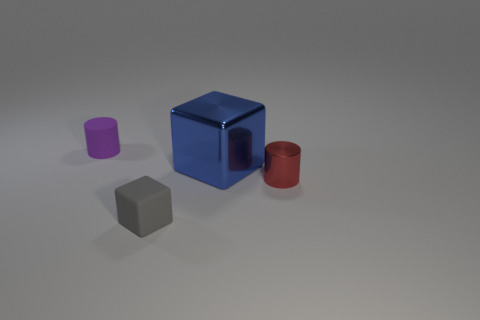Can you describe how light and shadows contribute to the overall composition? The interplay of light and shadow on the surfaces of the objects adds depth and dimension to the composition. The lighting accentuates the geometry of the shapes and helps to distinguish between the objects, making the scene more visually engaging. 